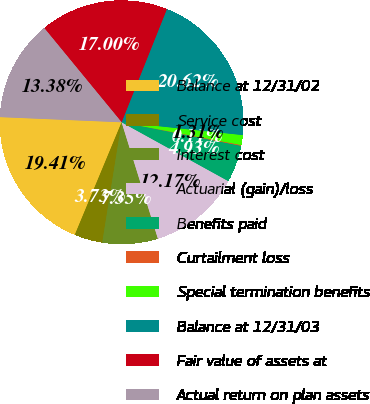Convert chart to OTSL. <chart><loc_0><loc_0><loc_500><loc_500><pie_chart><fcel>Balance at 12/31/02<fcel>Service cost<fcel>Interest cost<fcel>Actuarial (gain)/loss<fcel>Benefits paid<fcel>Curtailment loss<fcel>Special termination benefits<fcel>Balance at 12/31/03<fcel>Fair value of assets at<fcel>Actual return on plan assets<nl><fcel>19.41%<fcel>3.73%<fcel>7.35%<fcel>12.17%<fcel>4.93%<fcel>0.11%<fcel>1.31%<fcel>20.62%<fcel>17.0%<fcel>13.38%<nl></chart> 